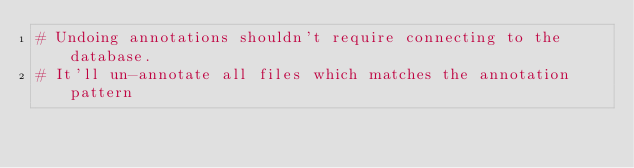Convert code to text. <code><loc_0><loc_0><loc_500><loc_500><_Ruby_># Undoing annotations shouldn't require connecting to the database.
# It'll un-annotate all files which matches the annotation pattern
</code> 